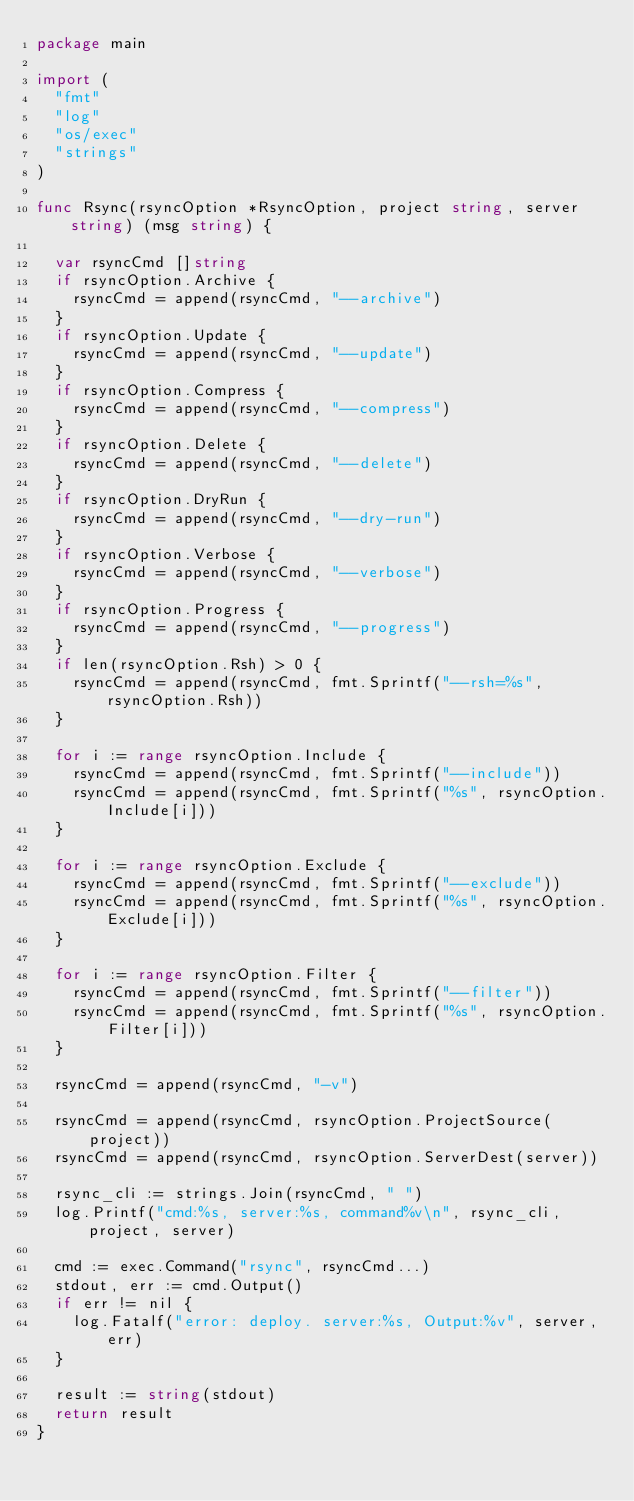Convert code to text. <code><loc_0><loc_0><loc_500><loc_500><_Go_>package main

import (
	"fmt"
	"log"
	"os/exec"
	"strings"
)

func Rsync(rsyncOption *RsyncOption, project string, server string) (msg string) {

	var rsyncCmd []string
	if rsyncOption.Archive {
		rsyncCmd = append(rsyncCmd, "--archive")
	}
	if rsyncOption.Update {
		rsyncCmd = append(rsyncCmd, "--update")
	}
	if rsyncOption.Compress {
		rsyncCmd = append(rsyncCmd, "--compress")
	}
	if rsyncOption.Delete {
		rsyncCmd = append(rsyncCmd, "--delete")
	}
	if rsyncOption.DryRun {
		rsyncCmd = append(rsyncCmd, "--dry-run")
	}
	if rsyncOption.Verbose {
		rsyncCmd = append(rsyncCmd, "--verbose")
	}
	if rsyncOption.Progress {
		rsyncCmd = append(rsyncCmd, "--progress")
	}
	if len(rsyncOption.Rsh) > 0 {
		rsyncCmd = append(rsyncCmd, fmt.Sprintf("--rsh=%s", rsyncOption.Rsh))
	}

	for i := range rsyncOption.Include {
		rsyncCmd = append(rsyncCmd, fmt.Sprintf("--include"))
		rsyncCmd = append(rsyncCmd, fmt.Sprintf("%s", rsyncOption.Include[i]))
	}

	for i := range rsyncOption.Exclude {
		rsyncCmd = append(rsyncCmd, fmt.Sprintf("--exclude"))
		rsyncCmd = append(rsyncCmd, fmt.Sprintf("%s", rsyncOption.Exclude[i]))
	}

	for i := range rsyncOption.Filter {
		rsyncCmd = append(rsyncCmd, fmt.Sprintf("--filter"))
		rsyncCmd = append(rsyncCmd, fmt.Sprintf("%s", rsyncOption.Filter[i]))
	}

	rsyncCmd = append(rsyncCmd, "-v")

	rsyncCmd = append(rsyncCmd, rsyncOption.ProjectSource(project))
	rsyncCmd = append(rsyncCmd, rsyncOption.ServerDest(server))

	rsync_cli := strings.Join(rsyncCmd, " ")
	log.Printf("cmd:%s, server:%s, command%v\n", rsync_cli, project, server)

	cmd := exec.Command("rsync", rsyncCmd...)
	stdout, err := cmd.Output()
	if err != nil {
		log.Fatalf("error: deploy. server:%s, Output:%v", server, err)
	}

	result := string(stdout)
	return result
}
</code> 